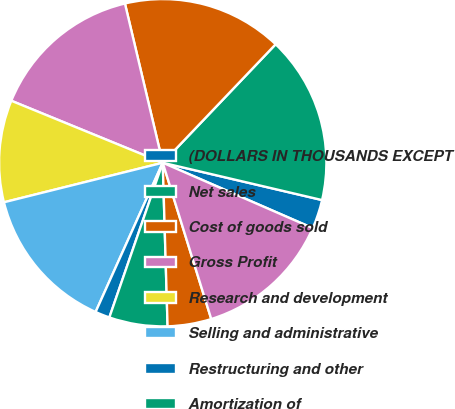Convert chart. <chart><loc_0><loc_0><loc_500><loc_500><pie_chart><fcel>(DOLLARS IN THOUSANDS EXCEPT<fcel>Net sales<fcel>Cost of goods sold<fcel>Gross Profit<fcel>Research and development<fcel>Selling and administrative<fcel>Restructuring and other<fcel>Amortization of<fcel>Gains on sale of assets<fcel>Operating Profit<nl><fcel>2.88%<fcel>16.55%<fcel>15.83%<fcel>15.11%<fcel>10.07%<fcel>14.39%<fcel>1.44%<fcel>5.76%<fcel>4.32%<fcel>13.67%<nl></chart> 